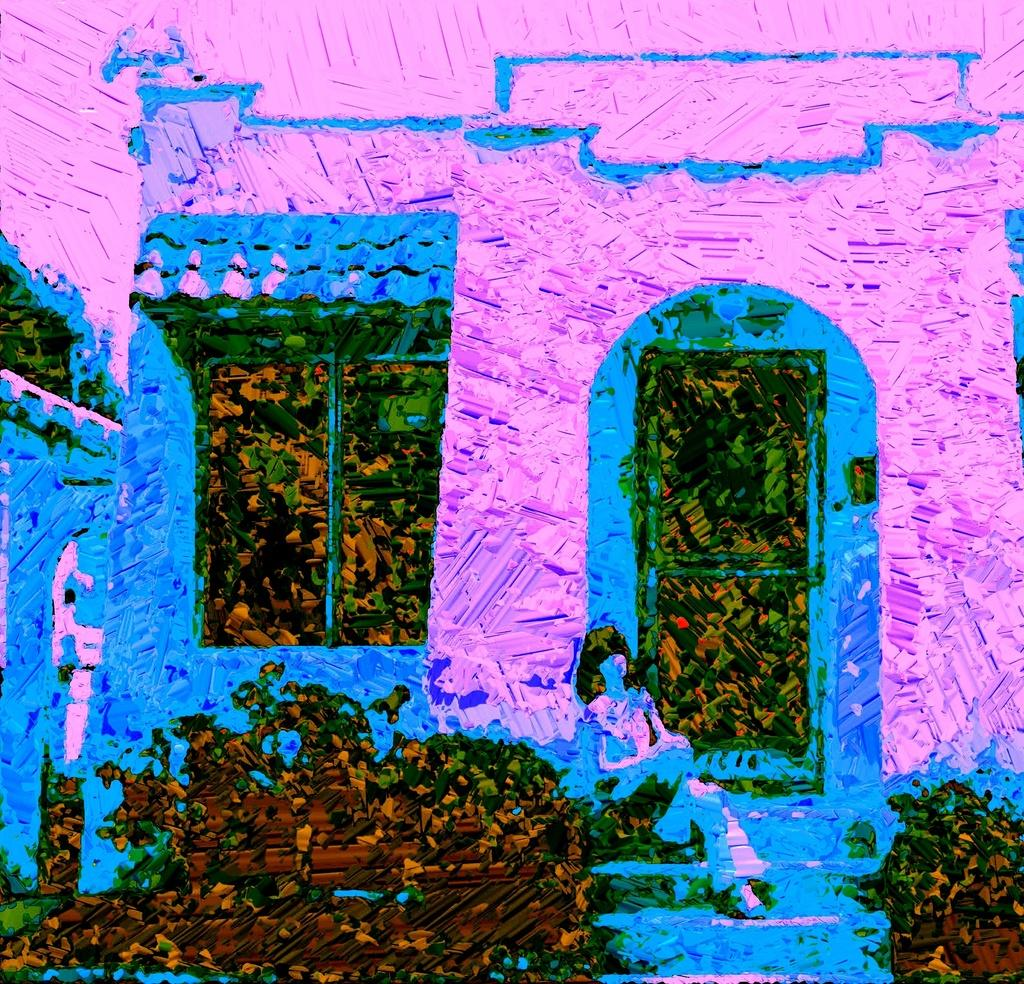What type of image is being described? The image is an edited picture. What can be seen in the front of the image? There are green color things in the front of the image. What colors are included in the image? The color of the image includes blue and pink. What type of haircut does the toad have in the image? There is no toad present in the image, so it is not possible to determine the type of haircut it might have. 